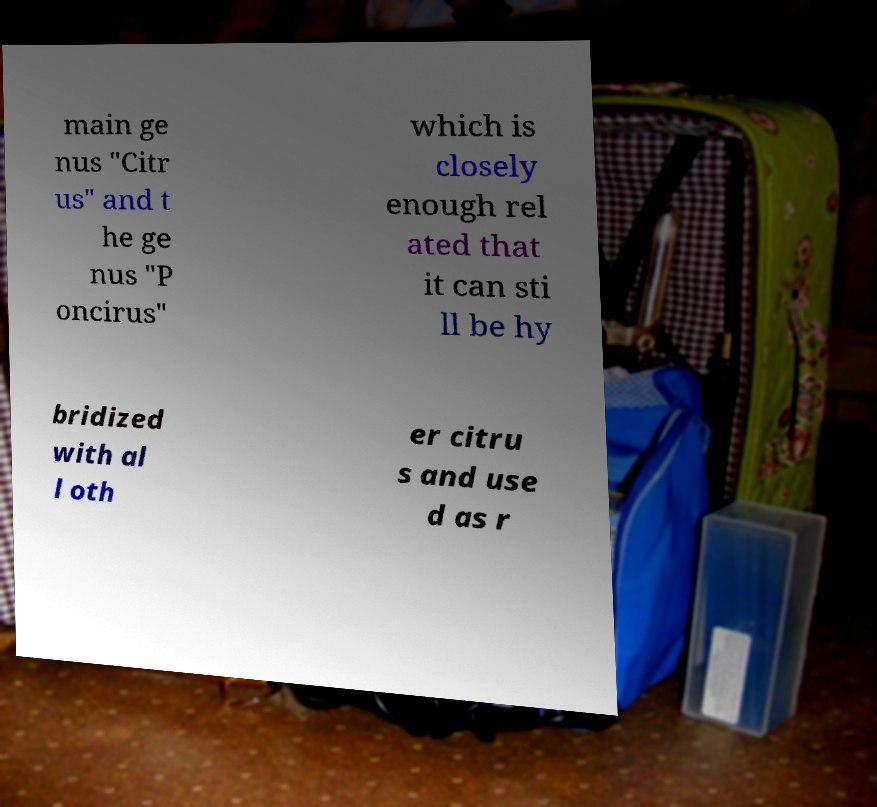Please read and relay the text visible in this image. What does it say? main ge nus "Citr us" and t he ge nus "P oncirus" which is closely enough rel ated that it can sti ll be hy bridized with al l oth er citru s and use d as r 